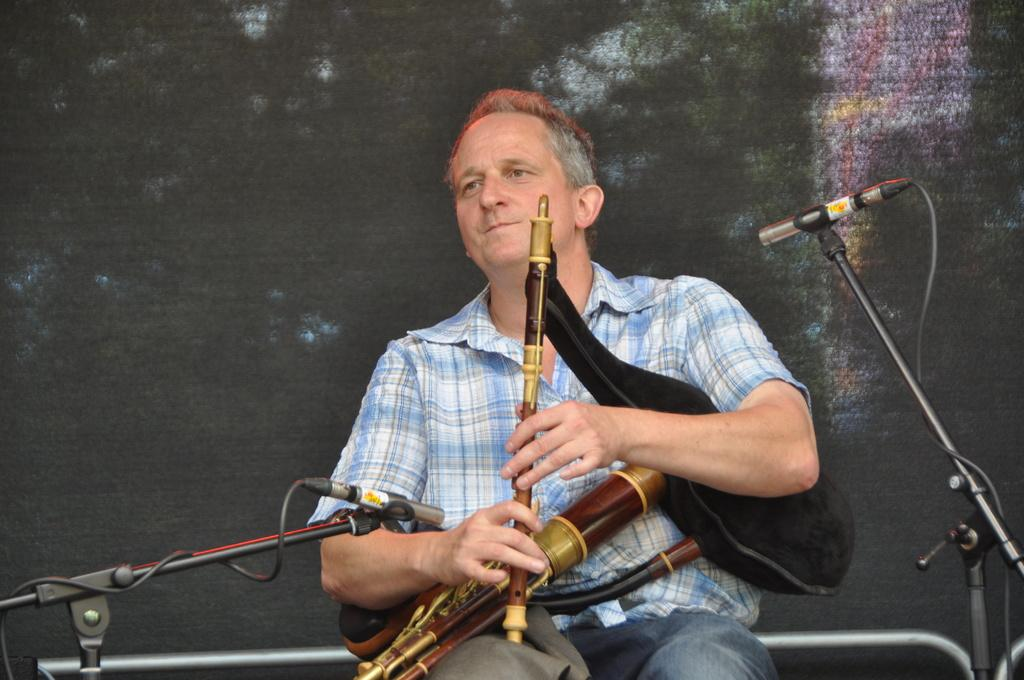What is the man in the image doing? The man is sitting and holding musical instruments in his hands. What can be seen near the man in the image? There are stands with microphones in the image. What is visible on the wall in the background of the image? There is a painting on the wall in the background of the image. What type of cherries are being used as part of the science apparatus in the image? There are no cherries or science apparatus present in the image. 